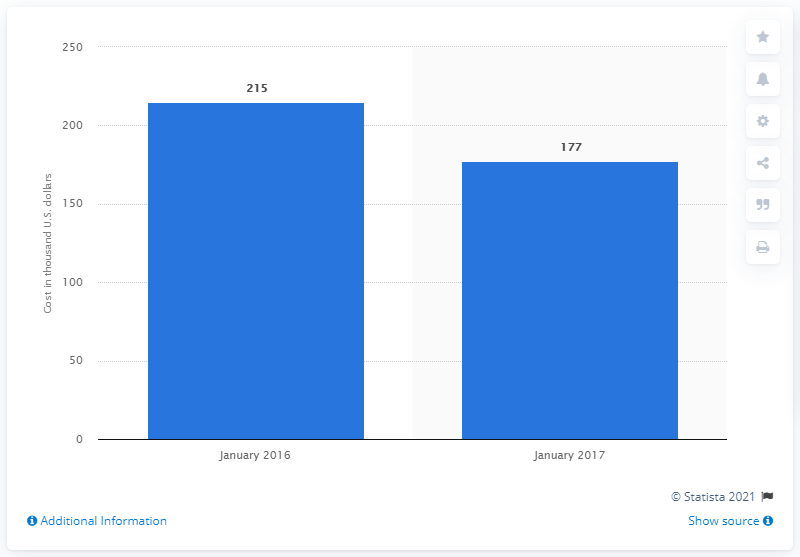Mention a couple of crucial points in this snapshot. In 2016, the average cost of a 30-second commercial during an episode of "Scandal" was approximately $215. 